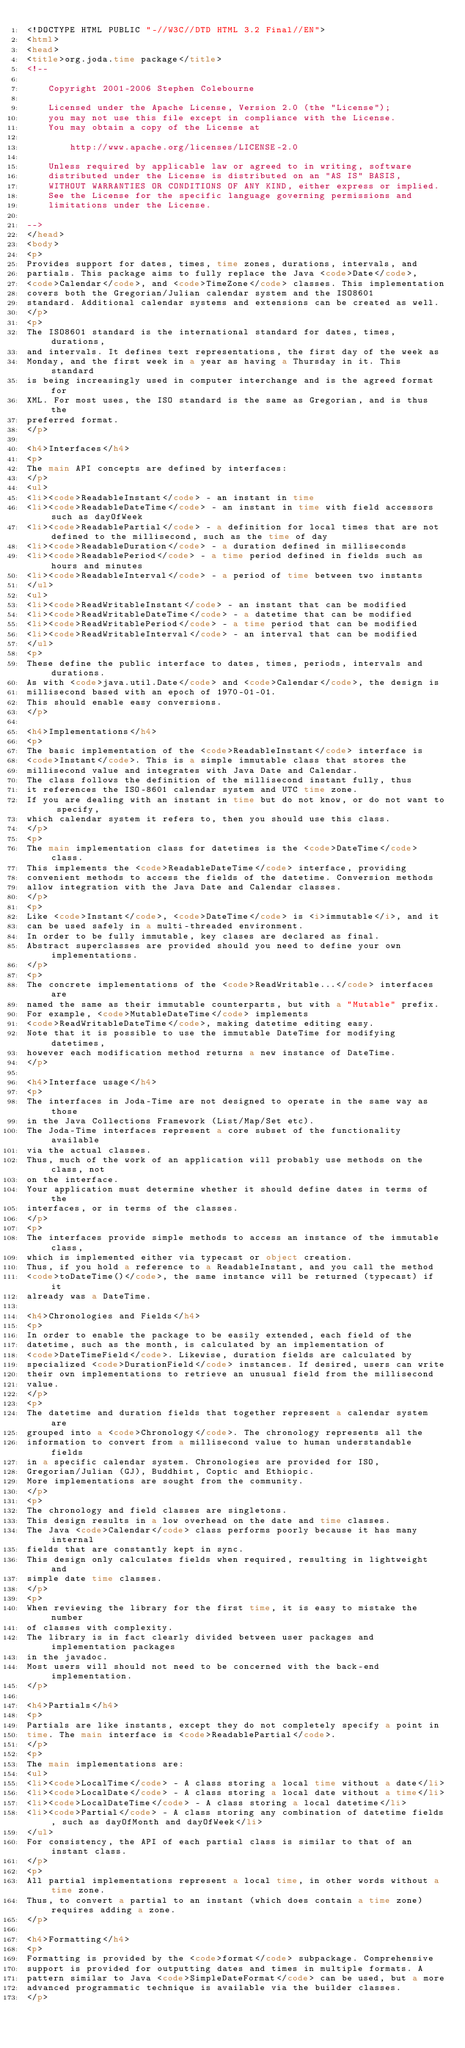<code> <loc_0><loc_0><loc_500><loc_500><_HTML_><!DOCTYPE HTML PUBLIC "-//W3C//DTD HTML 3.2 Final//EN">
<html>
<head>
<title>org.joda.time package</title>
<!--

    Copyright 2001-2006 Stephen Colebourne
  
    Licensed under the Apache License, Version 2.0 (the "License");
    you may not use this file except in compliance with the License.
    You may obtain a copy of the License at
  
        http://www.apache.org/licenses/LICENSE-2.0
  
    Unless required by applicable law or agreed to in writing, software
    distributed under the License is distributed on an "AS IS" BASIS,
    WITHOUT WARRANTIES OR CONDITIONS OF ANY KIND, either express or implied.
    See the License for the specific language governing permissions and
    limitations under the License.

-->
</head>
<body>
<p>
Provides support for dates, times, time zones, durations, intervals, and
partials. This package aims to fully replace the Java <code>Date</code>,
<code>Calendar</code>, and <code>TimeZone</code> classes. This implementation
covers both the Gregorian/Julian calendar system and the ISO8601
standard. Additional calendar systems and extensions can be created as well.
</p>
<p>
The ISO8601 standard is the international standard for dates, times, durations,
and intervals. It defines text representations, the first day of the week as
Monday, and the first week in a year as having a Thursday in it. This standard
is being increasingly used in computer interchange and is the agreed format for
XML. For most uses, the ISO standard is the same as Gregorian, and is thus the
preferred format.
</p>

<h4>Interfaces</h4>
<p>
The main API concepts are defined by interfaces:
</p>
<ul>
<li><code>ReadableInstant</code> - an instant in time
<li><code>ReadableDateTime</code> - an instant in time with field accessors such as dayOfWeek
<li><code>ReadablePartial</code> - a definition for local times that are not defined to the millisecond, such as the time of day
<li><code>ReadableDuration</code> - a duration defined in milliseconds
<li><code>ReadablePeriod</code> - a time period defined in fields such as hours and minutes
<li><code>ReadableInterval</code> - a period of time between two instants
</ul>
<ul>
<li><code>ReadWritableInstant</code> - an instant that can be modified
<li><code>ReadWritableDateTime</code> - a datetime that can be modified
<li><code>ReadWritablePeriod</code> - a time period that can be modified
<li><code>ReadWritableInterval</code> - an interval that can be modified
</ul>
<p>
These define the public interface to dates, times, periods, intervals and durations.
As with <code>java.util.Date</code> and <code>Calendar</code>, the design is
millisecond based with an epoch of 1970-01-01.
This should enable easy conversions.
</p>

<h4>Implementations</h4>
<p>
The basic implementation of the <code>ReadableInstant</code> interface is
<code>Instant</code>. This is a simple immutable class that stores the
millisecond value and integrates with Java Date and Calendar.
The class follows the definition of the millisecond instant fully, thus
it references the ISO-8601 calendar system and UTC time zone.
If you are dealing with an instant in time but do not know, or do not want to specify,
which calendar system it refers to, then you should use this class.
</p>
<p>
The main implementation class for datetimes is the <code>DateTime</code> class.
This implements the <code>ReadableDateTime</code> interface, providing
convenient methods to access the fields of the datetime. Conversion methods
allow integration with the Java Date and Calendar classes.
</p>
<p>
Like <code>Instant</code>, <code>DateTime</code> is <i>immutable</i>, and it
can be used safely in a multi-threaded environment. 
In order to be fully immutable, key clases are declared as final.
Abstract superclasses are provided should you need to define your own implementations.
</p>
<p>
The concrete implementations of the <code>ReadWritable...</code> interfaces are
named the same as their immutable counterparts, but with a "Mutable" prefix.
For example, <code>MutableDateTime</code> implements
<code>ReadWritableDateTime</code>, making datetime editing easy.
Note that it is possible to use the immutable DateTime for modifying datetimes,
however each modification method returns a new instance of DateTime.
</p>

<h4>Interface usage</h4>
<p>
The interfaces in Joda-Time are not designed to operate in the same way as those
in the Java Collections Framework (List/Map/Set etc).
The Joda-Time interfaces represent a core subset of the functionality available
via the actual classes.
Thus, much of the work of an application will probably use methods on the class, not
on the interface.
Your application must determine whether it should define dates in terms of the
interfaces, or in terms of the classes.
</p>
<p>
The interfaces provide simple methods to access an instance of the immutable class,
which is implemented either via typecast or object creation.
Thus, if you hold a reference to a ReadableInstant, and you call the method
<code>toDateTime()</code>, the same instance will be returned (typecast) if it
already was a DateTime.

<h4>Chronologies and Fields</h4>
<p>
In order to enable the package to be easily extended, each field of the
datetime, such as the month, is calculated by an implementation of
<code>DateTimeField</code>. Likewise, duration fields are calculated by
specialized <code>DurationField</code> instances. If desired, users can write
their own implementations to retrieve an unusual field from the millisecond
value.
</p>
<p>
The datetime and duration fields that together represent a calendar system are
grouped into a <code>Chronology</code>. The chronology represents all the
information to convert from a millisecond value to human understandable fields
in a specific calendar system. Chronologies are provided for ISO,
Gregorian/Julian (GJ), Buddhist, Coptic and Ethiopic.
More implementations are sought from the community.
</p>
<p>
The chronology and field classes are singletons.
This design results in a low overhead on the date and time classes.
The Java <code>Calendar</code> class performs poorly because it has many internal
fields that are constantly kept in sync.
This design only calculates fields when required, resulting in lightweight and
simple date time classes.
</p>
<p>
When reviewing the library for the first time, it is easy to mistake the number
of classes with complexity.
The library is in fact clearly divided between user packages and implementation packages
in the javadoc.
Most users will should not need to be concerned with the back-end implementation.
</p>

<h4>Partials</h4>
<p>
Partials are like instants, except they do not completely specify a point in
time. The main interface is <code>ReadablePartial</code>.
</p>
<p>
The main implementations are:
<ul>
<li><code>LocalTime</code> - A class storing a local time without a date</li>
<li><code>LocalDate</code> - A class storing a local date without a time</li>
<li><code>LocalDateTime</code> - A class storing a local datetime</li>
<li><code>Partial</code> - A class storing any combination of datetime fields, such as dayOfMonth and dayOfWeek</li>
</ul>
For consistency, the API of each partial class is similar to that of an instant class.
</p>
<p>
All partial implementations represent a local time, in other words without a time zone.
Thus, to convert a partial to an instant (which does contain a time zone) requires adding a zone.
</p>

<h4>Formatting</h4>
<p>
Formatting is provided by the <code>format</code> subpackage. Comprehensive
support is provided for outputting dates and times in multiple formats. A
pattern similar to Java <code>SimpleDateFormat</code> can be used, but a more
advanced programmatic technique is available via the builder classes.
</p>
</code> 